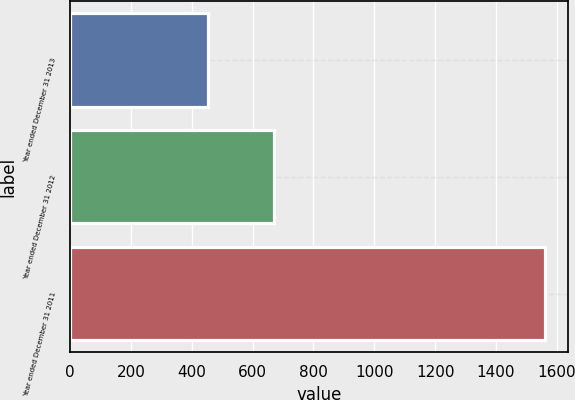<chart> <loc_0><loc_0><loc_500><loc_500><bar_chart><fcel>Year ended December 31 2013<fcel>Year ended December 31 2012<fcel>Year ended December 31 2011<nl><fcel>453<fcel>669<fcel>1560<nl></chart> 